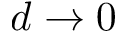<formula> <loc_0><loc_0><loc_500><loc_500>d \to 0</formula> 